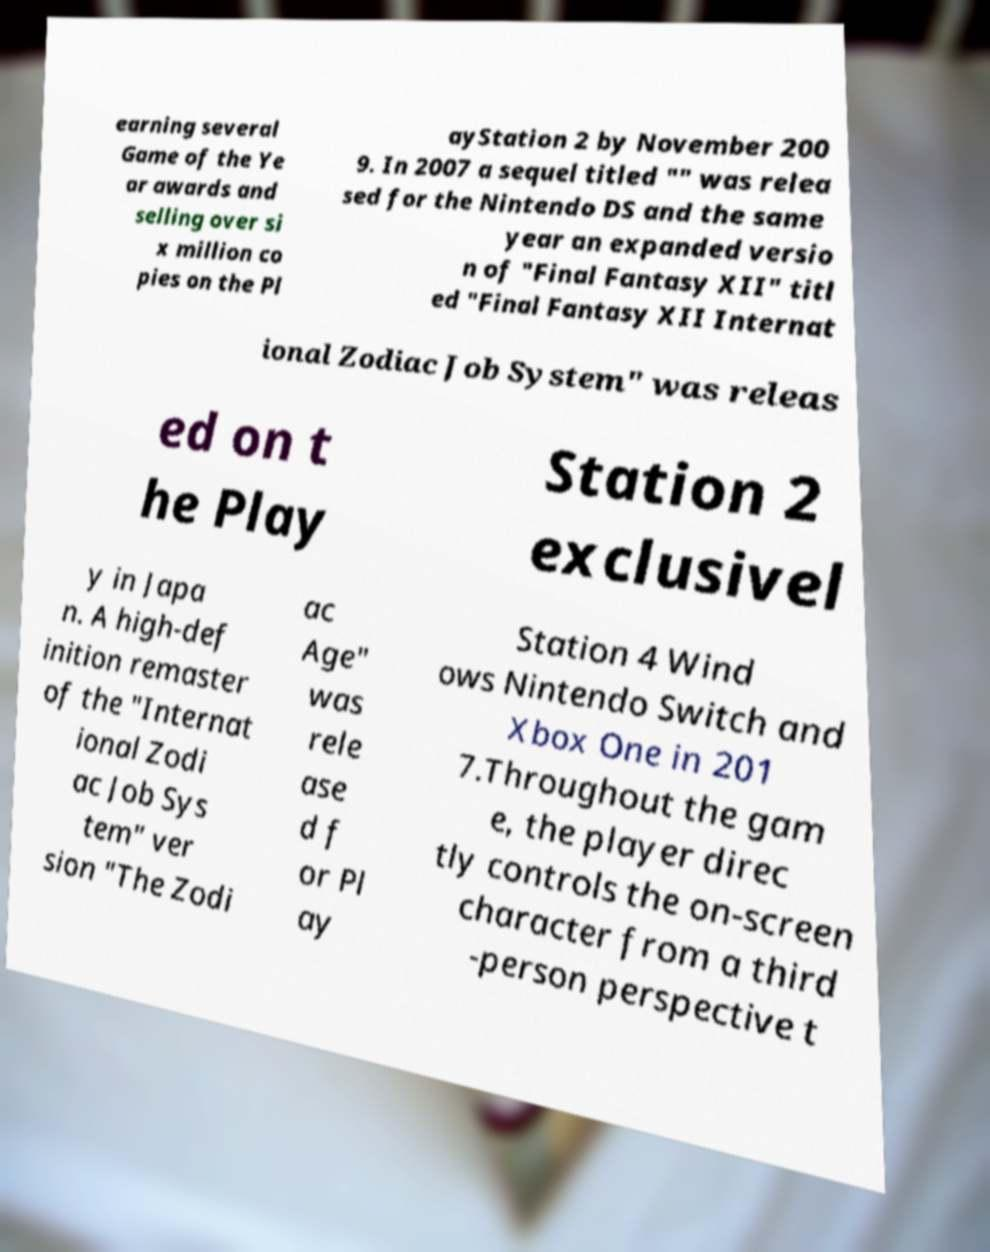Can you accurately transcribe the text from the provided image for me? earning several Game of the Ye ar awards and selling over si x million co pies on the Pl ayStation 2 by November 200 9. In 2007 a sequel titled "" was relea sed for the Nintendo DS and the same year an expanded versio n of "Final Fantasy XII" titl ed "Final Fantasy XII Internat ional Zodiac Job System" was releas ed on t he Play Station 2 exclusivel y in Japa n. A high-def inition remaster of the "Internat ional Zodi ac Job Sys tem" ver sion "The Zodi ac Age" was rele ase d f or Pl ay Station 4 Wind ows Nintendo Switch and Xbox One in 201 7.Throughout the gam e, the player direc tly controls the on-screen character from a third -person perspective t 